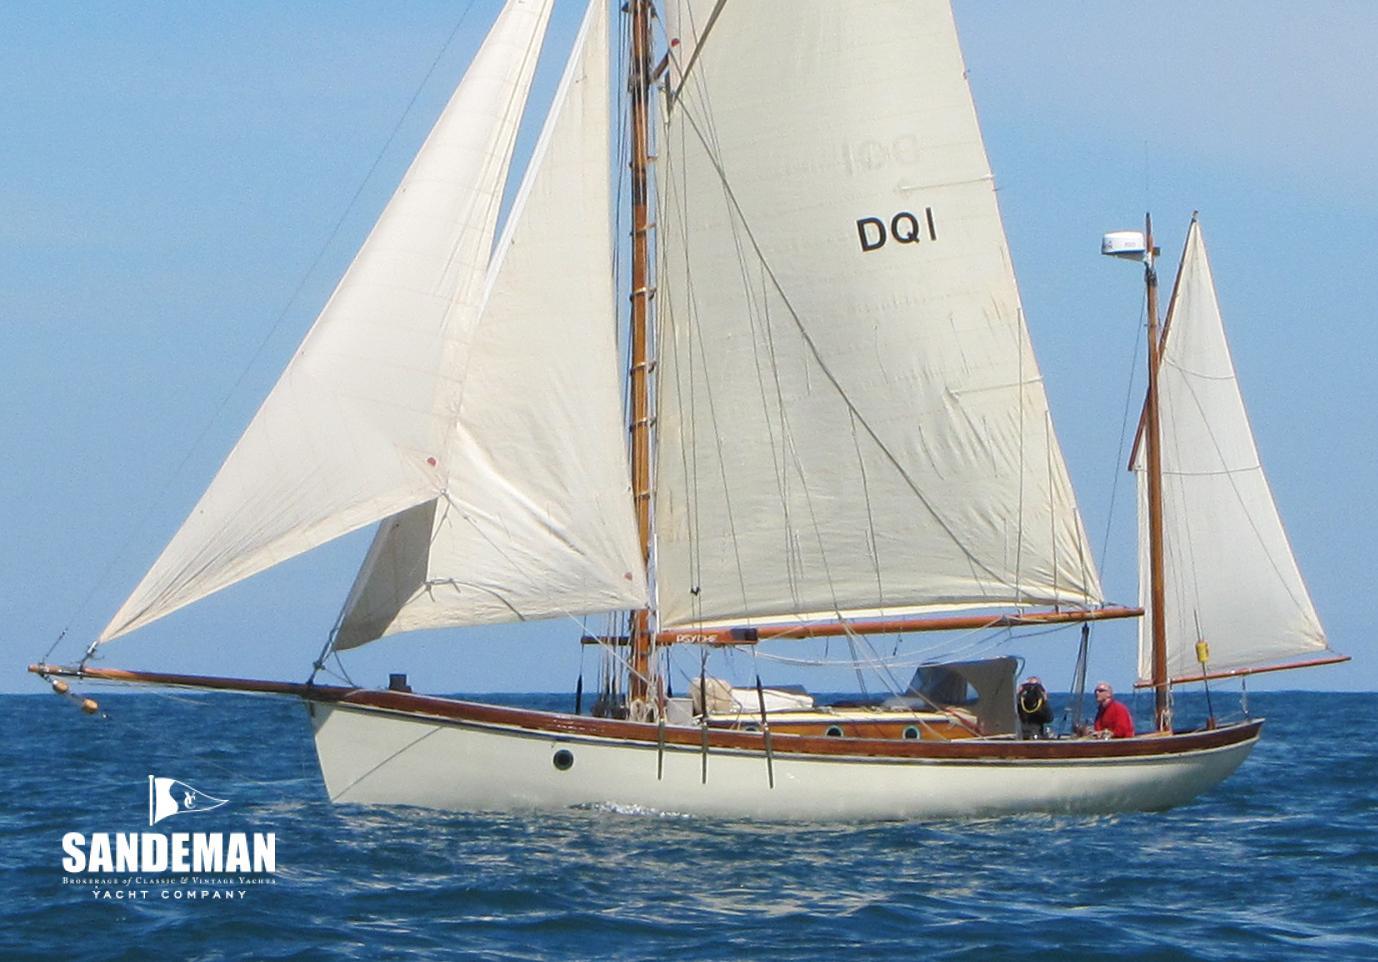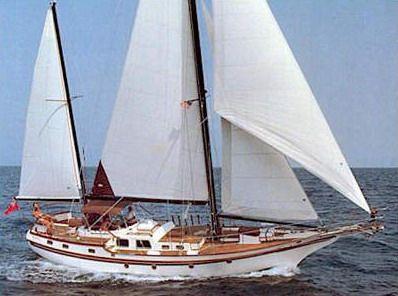The first image is the image on the left, the second image is the image on the right. Given the left and right images, does the statement "The left image shows a rightward-facing boat with a colored border on its leading unfurled sail and at least one colored canopy." hold true? Answer yes or no. No. The first image is the image on the left, the second image is the image on the right. Considering the images on both sides, is "The left and right image contains the same number of sailboats facing right." valid? Answer yes or no. No. 